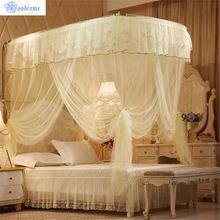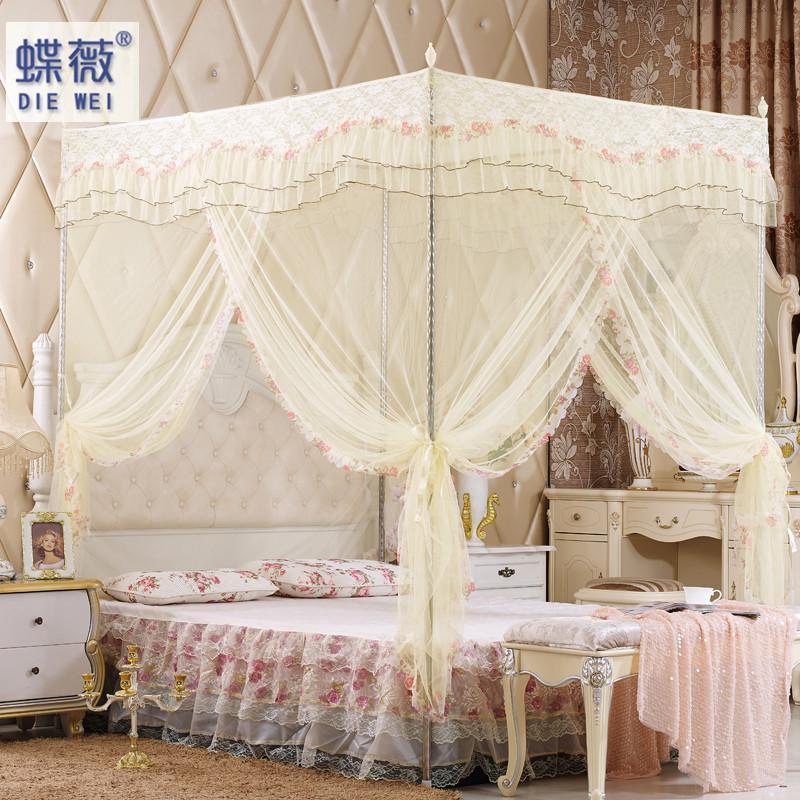The first image is the image on the left, the second image is the image on the right. Evaluate the accuracy of this statement regarding the images: "The wall and headboard behind at least one canopy bed feature a tufted, upholstered look.". Is it true? Answer yes or no. Yes. 